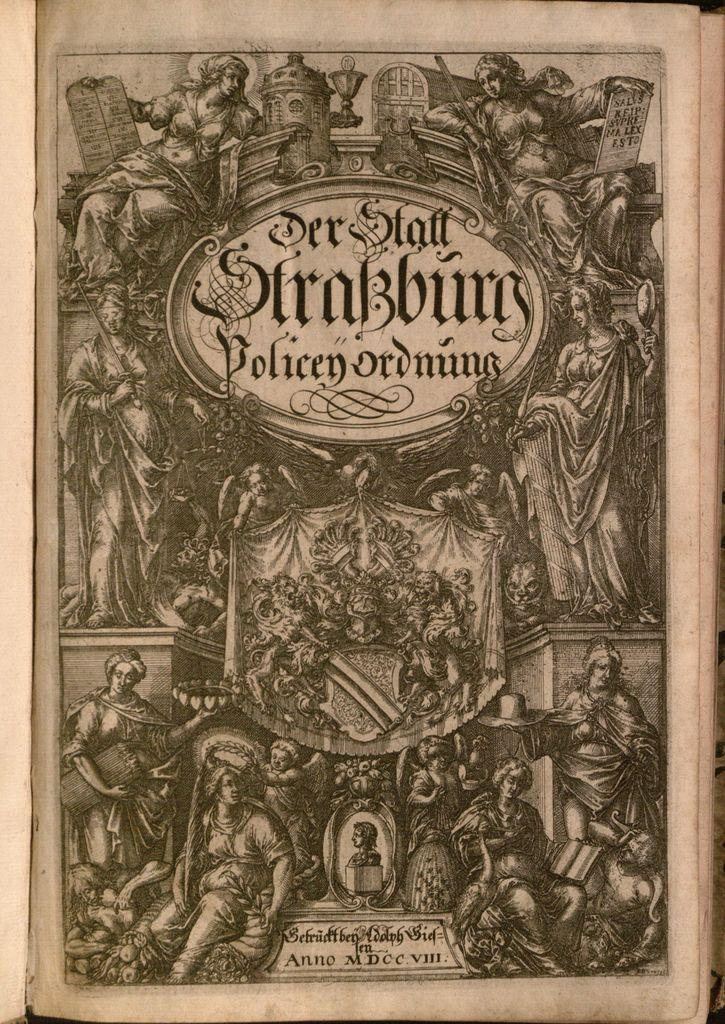Provide a one-sentence caption for the provided image. An old book cover with one of the words on it saying "policenordnung". 